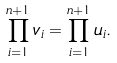Convert formula to latex. <formula><loc_0><loc_0><loc_500><loc_500>\prod _ { i = 1 } ^ { n + 1 } v _ { i } = \prod _ { i = 1 } ^ { n + 1 } u _ { i } .</formula> 